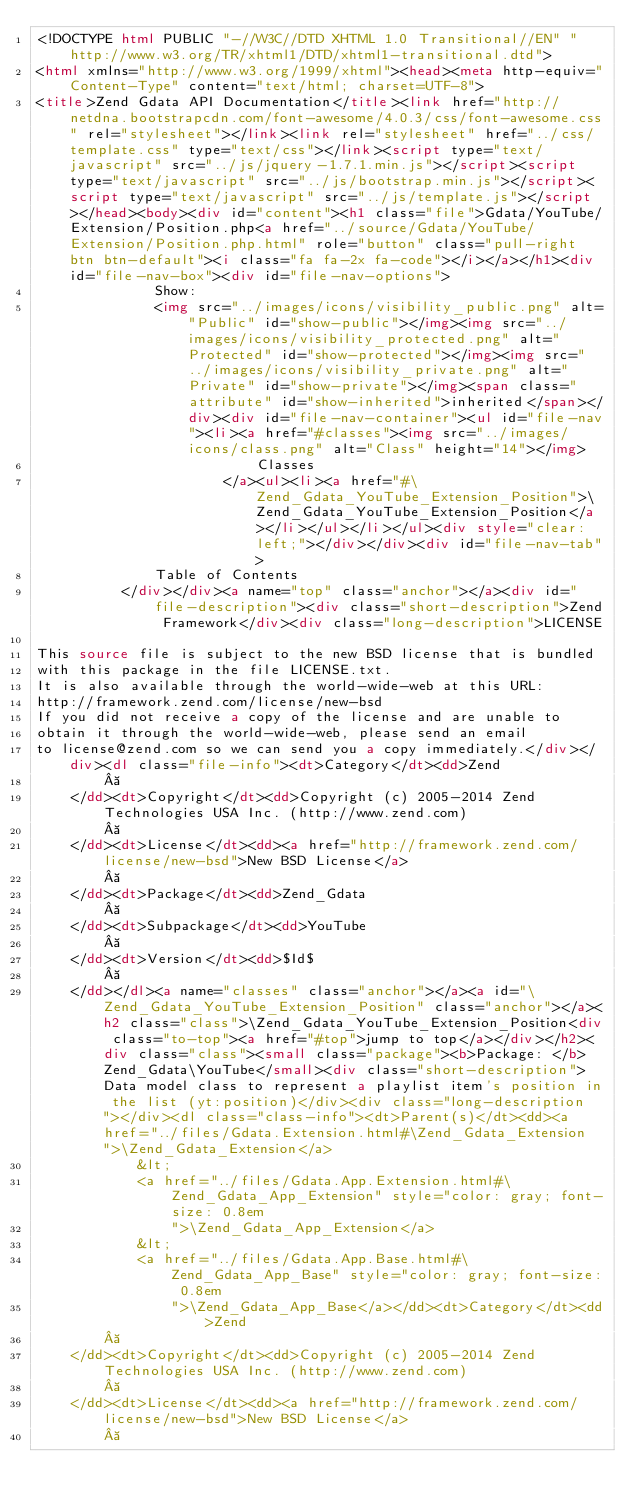<code> <loc_0><loc_0><loc_500><loc_500><_HTML_><!DOCTYPE html PUBLIC "-//W3C//DTD XHTML 1.0 Transitional//EN" "http://www.w3.org/TR/xhtml1/DTD/xhtml1-transitional.dtd">
<html xmlns="http://www.w3.org/1999/xhtml"><head><meta http-equiv="Content-Type" content="text/html; charset=UTF-8">
<title>Zend Gdata API Documentation</title><link href="http://netdna.bootstrapcdn.com/font-awesome/4.0.3/css/font-awesome.css" rel="stylesheet"></link><link rel="stylesheet" href="../css/template.css" type="text/css"></link><script type="text/javascript" src="../js/jquery-1.7.1.min.js"></script><script type="text/javascript" src="../js/bootstrap.min.js"></script><script type="text/javascript" src="../js/template.js"></script></head><body><div id="content"><h1 class="file">Gdata/YouTube/Extension/Position.php<a href="../source/Gdata/YouTube/Extension/Position.php.html" role="button" class="pull-right btn btn-default"><i class="fa fa-2x fa-code"></i></a></h1><div id="file-nav-box"><div id="file-nav-options">
              Show:
              <img src="../images/icons/visibility_public.png" alt="Public" id="show-public"></img><img src="../images/icons/visibility_protected.png" alt="Protected" id="show-protected"></img><img src="../images/icons/visibility_private.png" alt="Private" id="show-private"></img><span class="attribute" id="show-inherited">inherited</span></div><div id="file-nav-container"><ul id="file-nav"><li><a href="#classes"><img src="../images/icons/class.png" alt="Class" height="14"></img>
                          Classes
                      </a><ul><li><a href="#\Zend_Gdata_YouTube_Extension_Position">\Zend_Gdata_YouTube_Extension_Position</a></li></ul></li></ul><div style="clear: left;"></div></div><div id="file-nav-tab">
              Table of Contents
          </div></div><a name="top" class="anchor"></a><div id="file-description"><div class="short-description">Zend Framework</div><div class="long-description">LICENSE

This source file is subject to the new BSD license that is bundled
with this package in the file LICENSE.txt.
It is also available through the world-wide-web at this URL:
http://framework.zend.com/license/new-bsd
If you did not receive a copy of the license and are unable to
obtain it through the world-wide-web, please send an email
to license@zend.com so we can send you a copy immediately.</div></div><dl class="file-info"><dt>Category</dt><dd>Zend
         
    </dd><dt>Copyright</dt><dd>Copyright (c) 2005-2014 Zend Technologies USA Inc. (http://www.zend.com)
         
    </dd><dt>License</dt><dd><a href="http://framework.zend.com/license/new-bsd">New BSD License</a>
         
    </dd><dt>Package</dt><dd>Zend_Gdata
         
    </dd><dt>Subpackage</dt><dd>YouTube
         
    </dd><dt>Version</dt><dd>$Id$
         
    </dd></dl><a name="classes" class="anchor"></a><a id="\Zend_Gdata_YouTube_Extension_Position" class="anchor"></a><h2 class="class">\Zend_Gdata_YouTube_Extension_Position<div class="to-top"><a href="#top">jump to top</a></div></h2><div class="class"><small class="package"><b>Package: </b>Zend_Gdata\YouTube</small><div class="short-description">Data model class to represent a playlist item's position in the list (yt:position)</div><div class="long-description"></div><dl class="class-info"><dt>Parent(s)</dt><dd><a href="../files/Gdata.Extension.html#\Zend_Gdata_Extension">\Zend_Gdata_Extension</a>
            &lt;
            <a href="../files/Gdata.App.Extension.html#\Zend_Gdata_App_Extension" style="color: gray; font-size: 0.8em
                ">\Zend_Gdata_App_Extension</a>
            &lt;
            <a href="../files/Gdata.App.Base.html#\Zend_Gdata_App_Base" style="color: gray; font-size: 0.8em
                ">\Zend_Gdata_App_Base</a></dd><dt>Category</dt><dd>Zend
         
    </dd><dt>Copyright</dt><dd>Copyright (c) 2005-2014 Zend Technologies USA Inc. (http://www.zend.com)
         
    </dd><dt>License</dt><dd><a href="http://framework.zend.com/license/new-bsd">New BSD License</a>
         </code> 